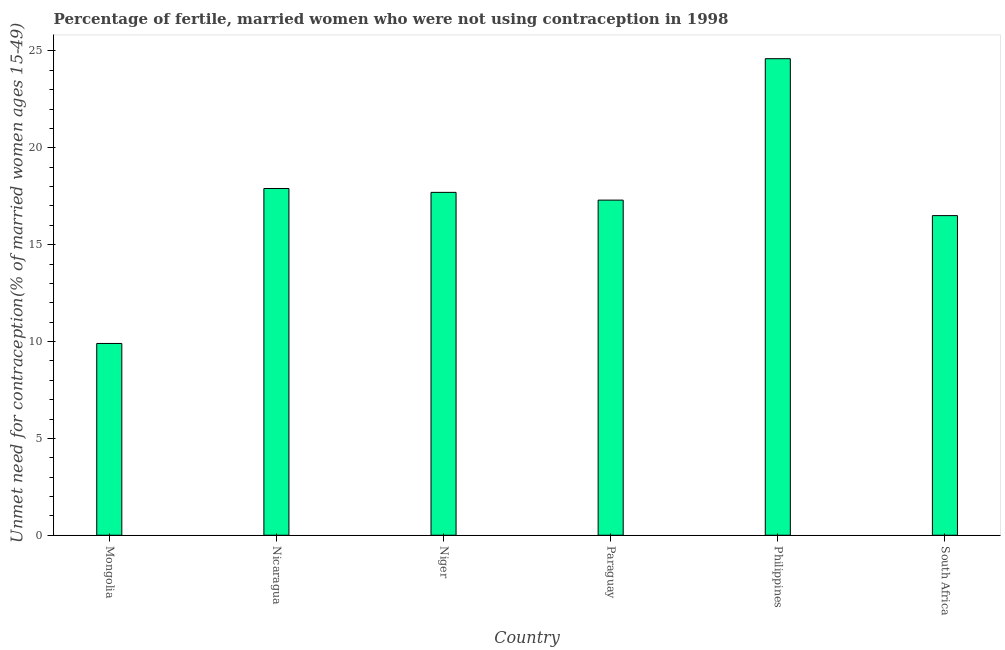Does the graph contain any zero values?
Provide a short and direct response. No. Does the graph contain grids?
Offer a very short reply. No. What is the title of the graph?
Your answer should be very brief. Percentage of fertile, married women who were not using contraception in 1998. What is the label or title of the Y-axis?
Your response must be concise.  Unmet need for contraception(% of married women ages 15-49). Across all countries, what is the maximum number of married women who are not using contraception?
Ensure brevity in your answer.  24.6. Across all countries, what is the minimum number of married women who are not using contraception?
Provide a short and direct response. 9.9. In which country was the number of married women who are not using contraception minimum?
Provide a succinct answer. Mongolia. What is the sum of the number of married women who are not using contraception?
Offer a very short reply. 103.9. What is the average number of married women who are not using contraception per country?
Your answer should be very brief. 17.32. What is the median number of married women who are not using contraception?
Give a very brief answer. 17.5. In how many countries, is the number of married women who are not using contraception greater than 12 %?
Offer a very short reply. 5. What is the ratio of the number of married women who are not using contraception in Nicaragua to that in Philippines?
Provide a short and direct response. 0.73. Is the number of married women who are not using contraception in Nicaragua less than that in Niger?
Your answer should be compact. No. Is the difference between the number of married women who are not using contraception in Nicaragua and Philippines greater than the difference between any two countries?
Offer a terse response. No. What is the difference between the highest and the lowest number of married women who are not using contraception?
Give a very brief answer. 14.7. In how many countries, is the number of married women who are not using contraception greater than the average number of married women who are not using contraception taken over all countries?
Your response must be concise. 3. How many bars are there?
Give a very brief answer. 6. Are all the bars in the graph horizontal?
Provide a short and direct response. No. What is the  Unmet need for contraception(% of married women ages 15-49) in Niger?
Keep it short and to the point. 17.7. What is the  Unmet need for contraception(% of married women ages 15-49) in Philippines?
Give a very brief answer. 24.6. What is the  Unmet need for contraception(% of married women ages 15-49) in South Africa?
Keep it short and to the point. 16.5. What is the difference between the  Unmet need for contraception(% of married women ages 15-49) in Mongolia and Nicaragua?
Provide a succinct answer. -8. What is the difference between the  Unmet need for contraception(% of married women ages 15-49) in Mongolia and Paraguay?
Provide a short and direct response. -7.4. What is the difference between the  Unmet need for contraception(% of married women ages 15-49) in Mongolia and Philippines?
Ensure brevity in your answer.  -14.7. What is the difference between the  Unmet need for contraception(% of married women ages 15-49) in Mongolia and South Africa?
Provide a succinct answer. -6.6. What is the difference between the  Unmet need for contraception(% of married women ages 15-49) in Nicaragua and South Africa?
Offer a very short reply. 1.4. What is the difference between the  Unmet need for contraception(% of married women ages 15-49) in Niger and Paraguay?
Provide a short and direct response. 0.4. What is the difference between the  Unmet need for contraception(% of married women ages 15-49) in Niger and Philippines?
Your response must be concise. -6.9. What is the difference between the  Unmet need for contraception(% of married women ages 15-49) in Paraguay and Philippines?
Ensure brevity in your answer.  -7.3. What is the difference between the  Unmet need for contraception(% of married women ages 15-49) in Paraguay and South Africa?
Keep it short and to the point. 0.8. What is the ratio of the  Unmet need for contraception(% of married women ages 15-49) in Mongolia to that in Nicaragua?
Your answer should be very brief. 0.55. What is the ratio of the  Unmet need for contraception(% of married women ages 15-49) in Mongolia to that in Niger?
Give a very brief answer. 0.56. What is the ratio of the  Unmet need for contraception(% of married women ages 15-49) in Mongolia to that in Paraguay?
Provide a succinct answer. 0.57. What is the ratio of the  Unmet need for contraception(% of married women ages 15-49) in Mongolia to that in Philippines?
Your answer should be very brief. 0.4. What is the ratio of the  Unmet need for contraception(% of married women ages 15-49) in Nicaragua to that in Paraguay?
Offer a very short reply. 1.03. What is the ratio of the  Unmet need for contraception(% of married women ages 15-49) in Nicaragua to that in Philippines?
Offer a terse response. 0.73. What is the ratio of the  Unmet need for contraception(% of married women ages 15-49) in Nicaragua to that in South Africa?
Your response must be concise. 1.08. What is the ratio of the  Unmet need for contraception(% of married women ages 15-49) in Niger to that in Paraguay?
Your answer should be compact. 1.02. What is the ratio of the  Unmet need for contraception(% of married women ages 15-49) in Niger to that in Philippines?
Your response must be concise. 0.72. What is the ratio of the  Unmet need for contraception(% of married women ages 15-49) in Niger to that in South Africa?
Keep it short and to the point. 1.07. What is the ratio of the  Unmet need for contraception(% of married women ages 15-49) in Paraguay to that in Philippines?
Offer a very short reply. 0.7. What is the ratio of the  Unmet need for contraception(% of married women ages 15-49) in Paraguay to that in South Africa?
Provide a short and direct response. 1.05. What is the ratio of the  Unmet need for contraception(% of married women ages 15-49) in Philippines to that in South Africa?
Your answer should be very brief. 1.49. 